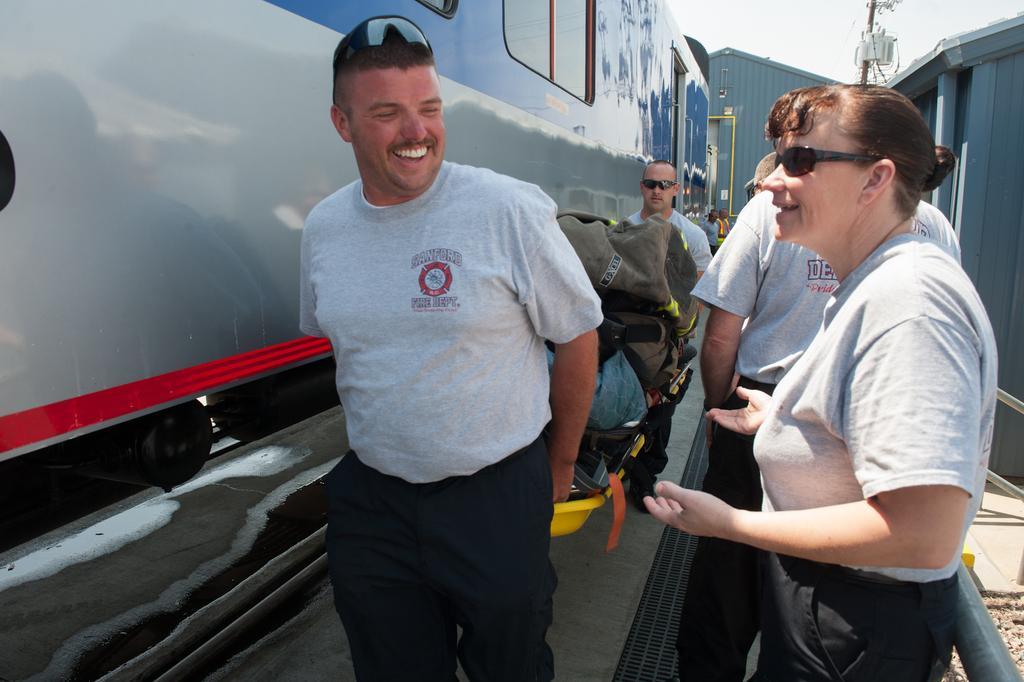Can you describe this image briefly? In the foreground of the picture we can see people, stretcher and other objects. On the left we can see a locomotive. On the right we can see railing, soil and construction. In the background we can see a shed and people. At the top we can see sky, cables and pole. 